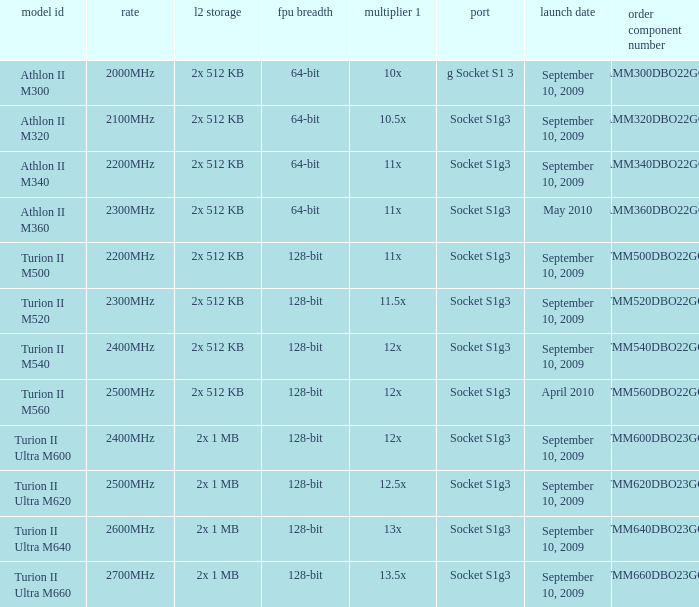What is the socket with an order part number of amm300dbo22gq and a September 10, 2009 release date? G socket s1 3. 